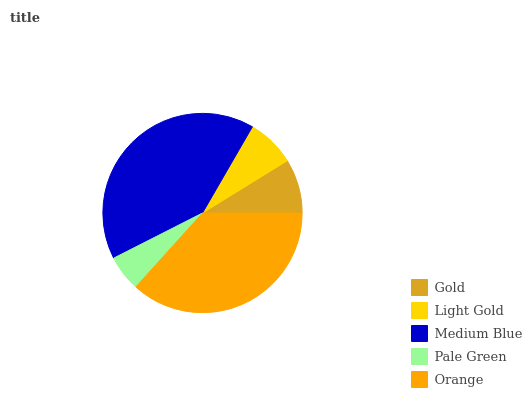Is Pale Green the minimum?
Answer yes or no. Yes. Is Medium Blue the maximum?
Answer yes or no. Yes. Is Light Gold the minimum?
Answer yes or no. No. Is Light Gold the maximum?
Answer yes or no. No. Is Gold greater than Light Gold?
Answer yes or no. Yes. Is Light Gold less than Gold?
Answer yes or no. Yes. Is Light Gold greater than Gold?
Answer yes or no. No. Is Gold less than Light Gold?
Answer yes or no. No. Is Gold the high median?
Answer yes or no. Yes. Is Gold the low median?
Answer yes or no. Yes. Is Orange the high median?
Answer yes or no. No. Is Pale Green the low median?
Answer yes or no. No. 